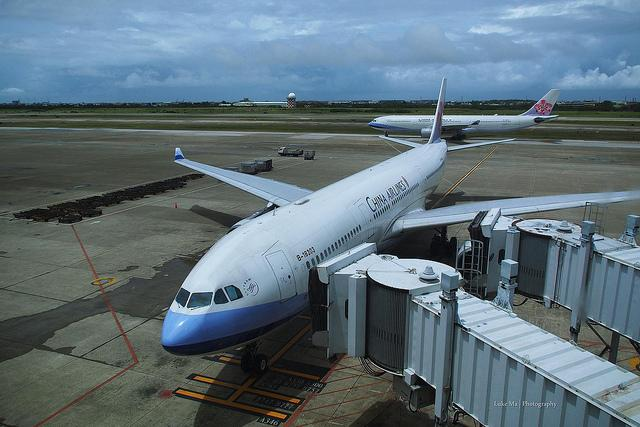What is the tunnel nearest the plane door called?

Choices:
A) jet bridge
B) air tunnel
C) luggage tunnel
D) escape tunnel jet bridge 